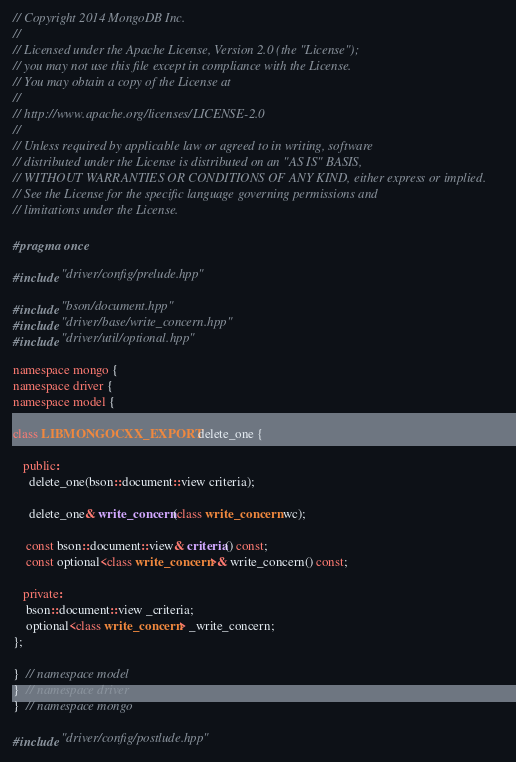Convert code to text. <code><loc_0><loc_0><loc_500><loc_500><_C++_>// Copyright 2014 MongoDB Inc.
//
// Licensed under the Apache License, Version 2.0 (the "License");
// you may not use this file except in compliance with the License.
// You may obtain a copy of the License at
//
// http://www.apache.org/licenses/LICENSE-2.0
//
// Unless required by applicable law or agreed to in writing, software
// distributed under the License is distributed on an "AS IS" BASIS,
// WITHOUT WARRANTIES OR CONDITIONS OF ANY KIND, either express or implied.
// See the License for the specific language governing permissions and
// limitations under the License.

#pragma once

#include "driver/config/prelude.hpp"

#include "bson/document.hpp"
#include "driver/base/write_concern.hpp"
#include "driver/util/optional.hpp"

namespace mongo {
namespace driver {
namespace model {

class LIBMONGOCXX_EXPORT delete_one {

   public:
     delete_one(bson::document::view criteria);

     delete_one& write_concern(class write_concern wc);

    const bson::document::view& criteria() const;
    const optional<class write_concern>& write_concern() const;

   private:
    bson::document::view _criteria;
    optional<class write_concern> _write_concern;
};

}  // namespace model
}  // namespace driver
}  // namespace mongo

#include "driver/config/postlude.hpp"
</code> 